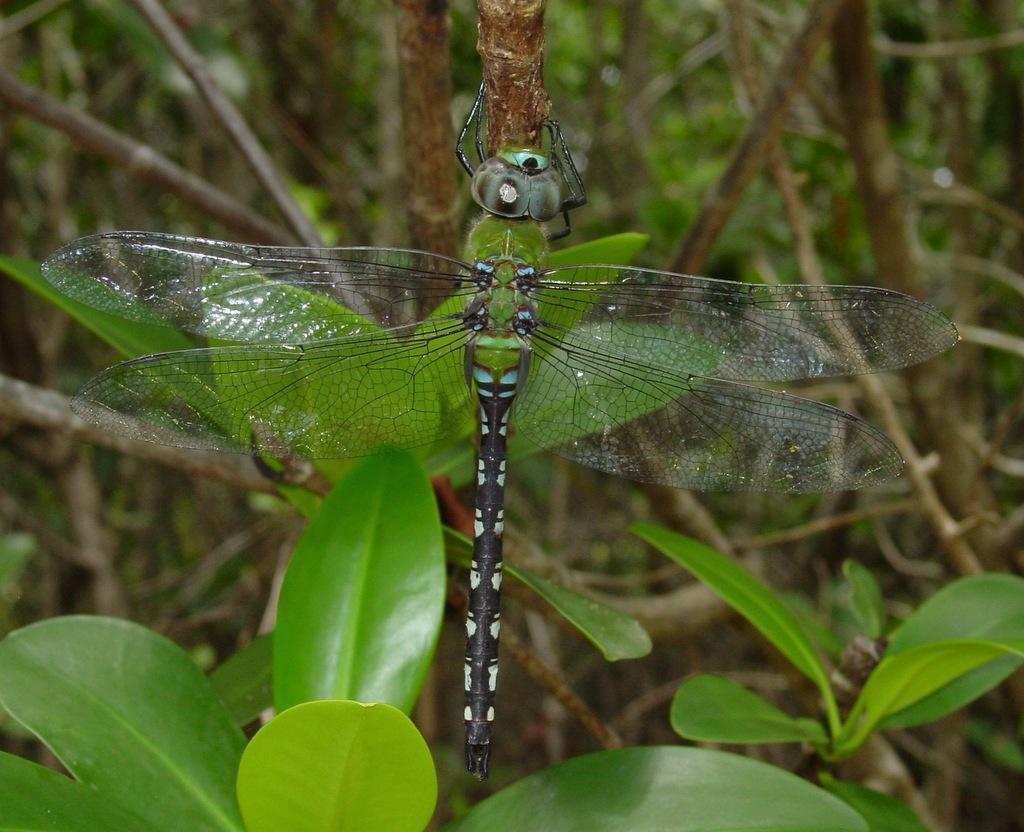Could you give a brief overview of what you see in this image? In this image there is a fly on the stem. At the bottom there are green leaves. In the background there are trees and wooden sticks. 